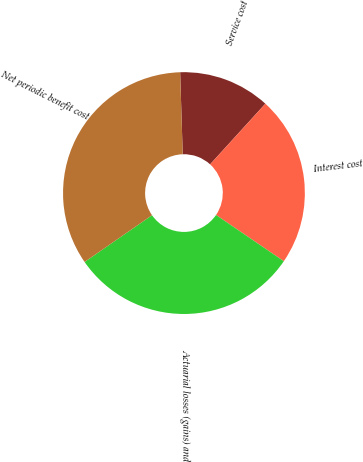Convert chart. <chart><loc_0><loc_0><loc_500><loc_500><pie_chart><fcel>Service cost<fcel>Interest cost<fcel>Actuarial losses (gains) and<fcel>Net periodic benefit cost<nl><fcel>12.26%<fcel>22.77%<fcel>30.82%<fcel>34.15%<nl></chart> 